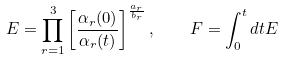<formula> <loc_0><loc_0><loc_500><loc_500>E = \prod _ { r = 1 } ^ { 3 } \left [ \frac { \alpha _ { r } ( 0 ) } { \alpha _ { r } ( t ) } \right ] ^ { \frac { a _ { r } } { b _ { r } } } , \quad F = \int ^ { t } _ { 0 } d t E</formula> 